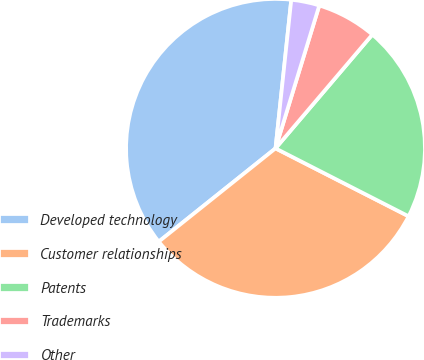<chart> <loc_0><loc_0><loc_500><loc_500><pie_chart><fcel>Developed technology<fcel>Customer relationships<fcel>Patents<fcel>Trademarks<fcel>Other<nl><fcel>37.41%<fcel>31.76%<fcel>21.29%<fcel>6.49%<fcel>3.05%<nl></chart> 